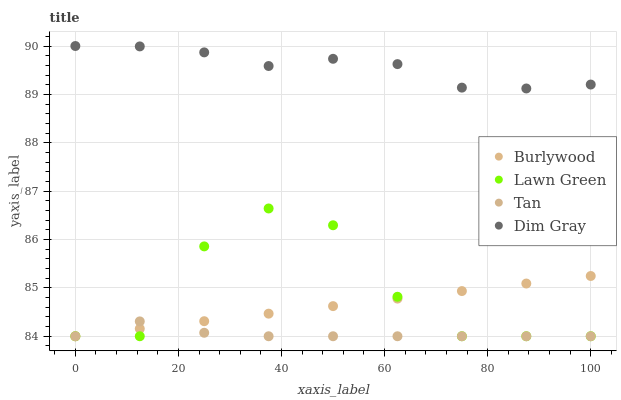Does Tan have the minimum area under the curve?
Answer yes or no. Yes. Does Dim Gray have the maximum area under the curve?
Answer yes or no. Yes. Does Lawn Green have the minimum area under the curve?
Answer yes or no. No. Does Lawn Green have the maximum area under the curve?
Answer yes or no. No. Is Burlywood the smoothest?
Answer yes or no. Yes. Is Lawn Green the roughest?
Answer yes or no. Yes. Is Tan the smoothest?
Answer yes or no. No. Is Tan the roughest?
Answer yes or no. No. Does Burlywood have the lowest value?
Answer yes or no. Yes. Does Dim Gray have the lowest value?
Answer yes or no. No. Does Dim Gray have the highest value?
Answer yes or no. Yes. Does Lawn Green have the highest value?
Answer yes or no. No. Is Lawn Green less than Dim Gray?
Answer yes or no. Yes. Is Dim Gray greater than Tan?
Answer yes or no. Yes. Does Lawn Green intersect Burlywood?
Answer yes or no. Yes. Is Lawn Green less than Burlywood?
Answer yes or no. No. Is Lawn Green greater than Burlywood?
Answer yes or no. No. Does Lawn Green intersect Dim Gray?
Answer yes or no. No. 